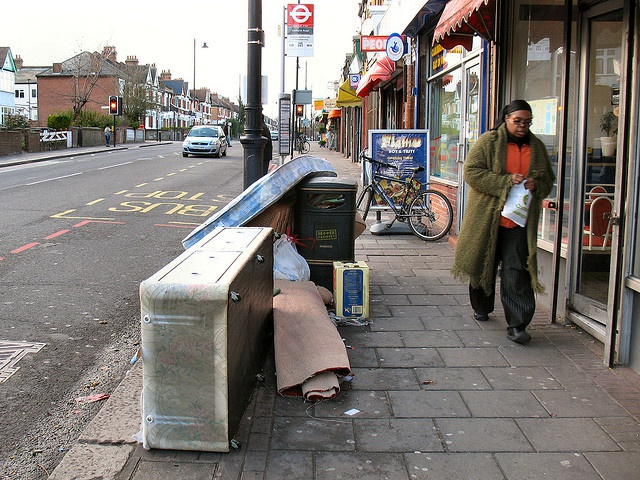Describe the objects in this image and their specific colors. I can see people in white, black, darkgreen, gray, and maroon tones, bicycle in white, black, gray, darkgray, and tan tones, chair in white, maroon, black, gray, and brown tones, car in white, black, gray, and darkgray tones, and potted plant in white, black, gray, and darkgray tones in this image. 